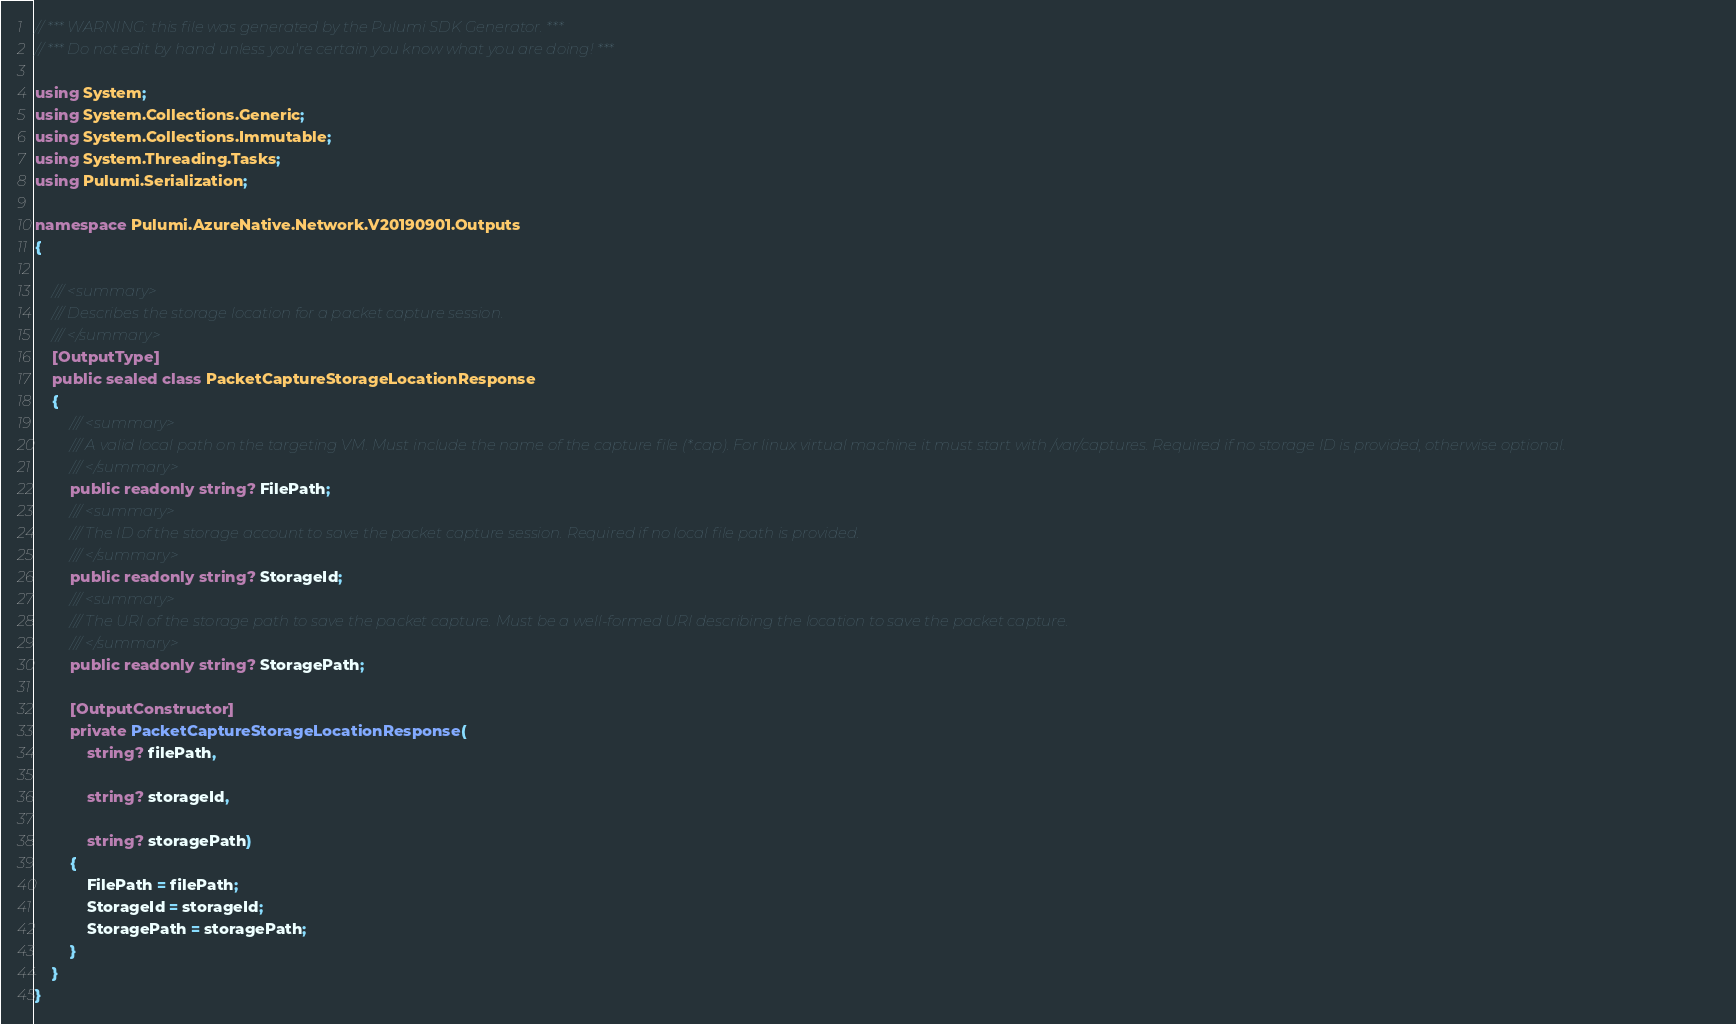Convert code to text. <code><loc_0><loc_0><loc_500><loc_500><_C#_>// *** WARNING: this file was generated by the Pulumi SDK Generator. ***
// *** Do not edit by hand unless you're certain you know what you are doing! ***

using System;
using System.Collections.Generic;
using System.Collections.Immutable;
using System.Threading.Tasks;
using Pulumi.Serialization;

namespace Pulumi.AzureNative.Network.V20190901.Outputs
{

    /// <summary>
    /// Describes the storage location for a packet capture session.
    /// </summary>
    [OutputType]
    public sealed class PacketCaptureStorageLocationResponse
    {
        /// <summary>
        /// A valid local path on the targeting VM. Must include the name of the capture file (*.cap). For linux virtual machine it must start with /var/captures. Required if no storage ID is provided, otherwise optional.
        /// </summary>
        public readonly string? FilePath;
        /// <summary>
        /// The ID of the storage account to save the packet capture session. Required if no local file path is provided.
        /// </summary>
        public readonly string? StorageId;
        /// <summary>
        /// The URI of the storage path to save the packet capture. Must be a well-formed URI describing the location to save the packet capture.
        /// </summary>
        public readonly string? StoragePath;

        [OutputConstructor]
        private PacketCaptureStorageLocationResponse(
            string? filePath,

            string? storageId,

            string? storagePath)
        {
            FilePath = filePath;
            StorageId = storageId;
            StoragePath = storagePath;
        }
    }
}
</code> 